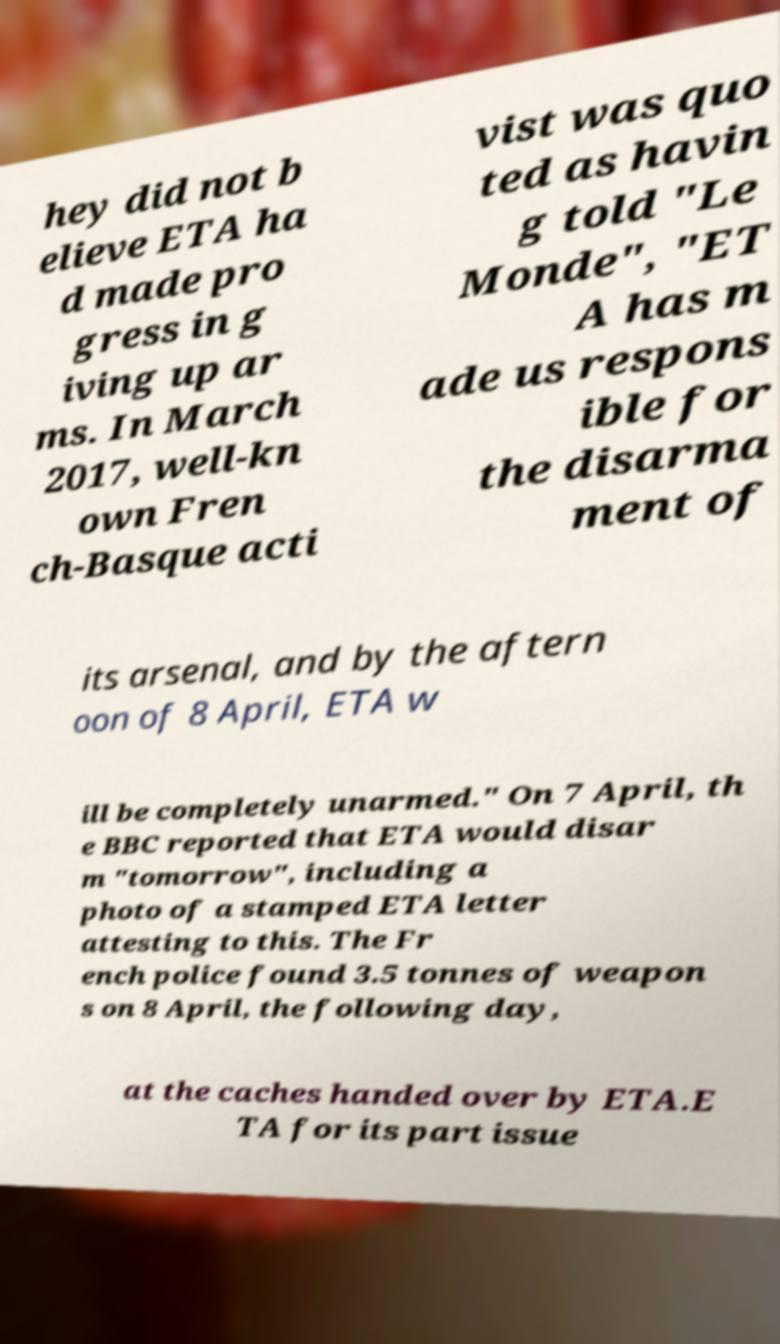Could you extract and type out the text from this image? hey did not b elieve ETA ha d made pro gress in g iving up ar ms. In March 2017, well-kn own Fren ch-Basque acti vist was quo ted as havin g told "Le Monde", "ET A has m ade us respons ible for the disarma ment of its arsenal, and by the aftern oon of 8 April, ETA w ill be completely unarmed." On 7 April, th e BBC reported that ETA would disar m "tomorrow", including a photo of a stamped ETA letter attesting to this. The Fr ench police found 3.5 tonnes of weapon s on 8 April, the following day, at the caches handed over by ETA.E TA for its part issue 